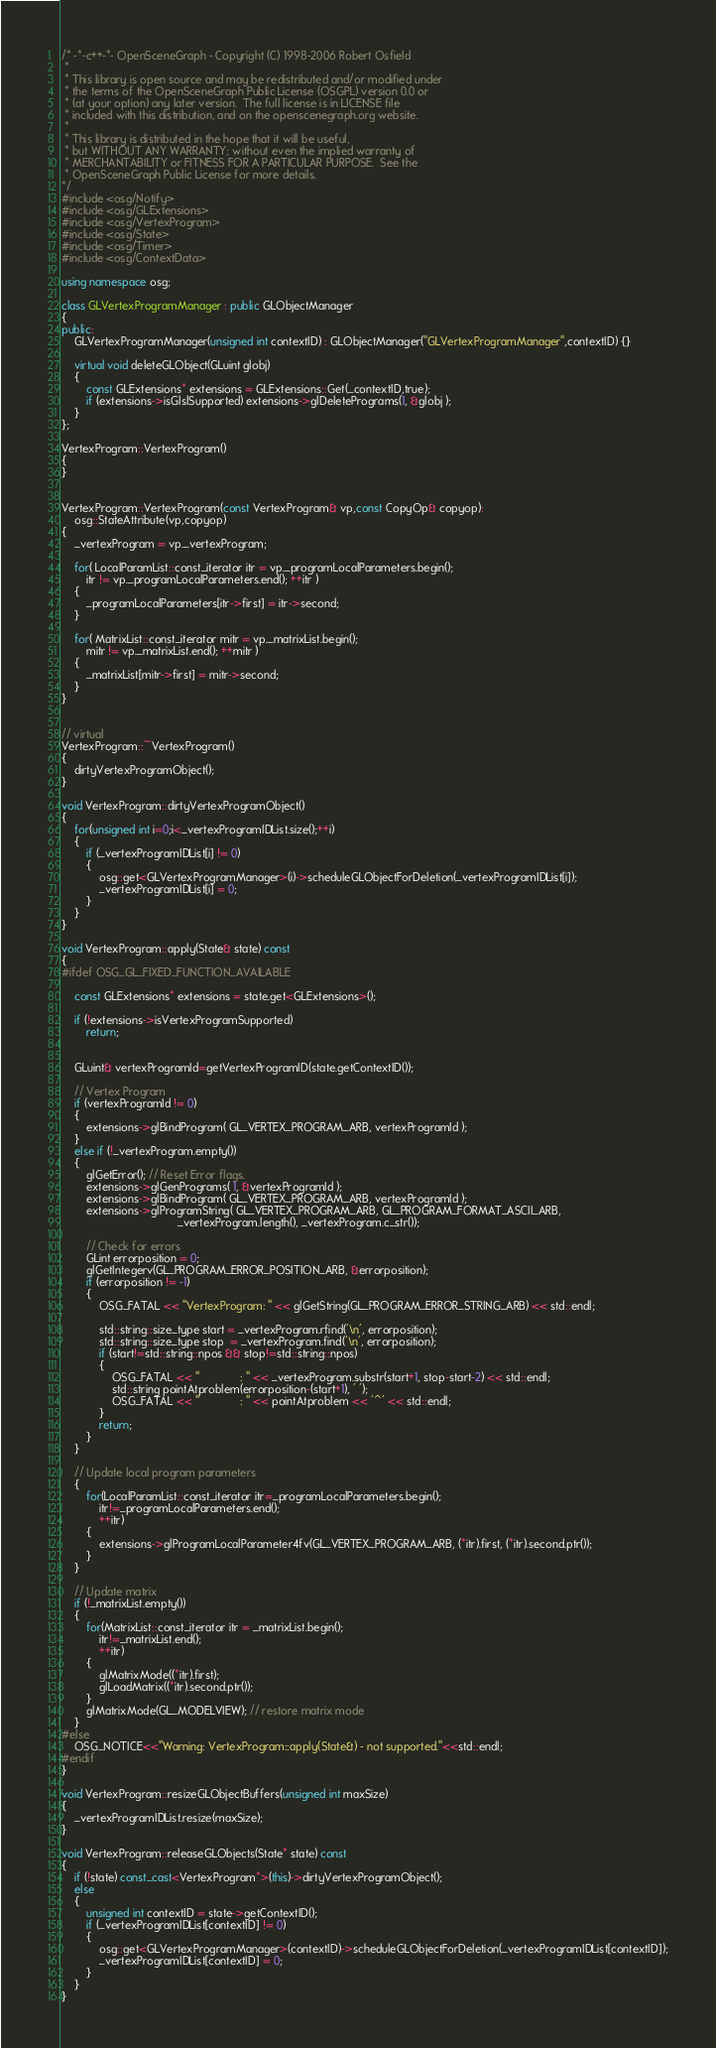Convert code to text. <code><loc_0><loc_0><loc_500><loc_500><_C++_>/* -*-c++-*- OpenSceneGraph - Copyright (C) 1998-2006 Robert Osfield
 *
 * This library is open source and may be redistributed and/or modified under
 * the terms of the OpenSceneGraph Public License (OSGPL) version 0.0 or
 * (at your option) any later version.  The full license is in LICENSE file
 * included with this distribution, and on the openscenegraph.org website.
 *
 * This library is distributed in the hope that it will be useful,
 * but WITHOUT ANY WARRANTY; without even the implied warranty of
 * MERCHANTABILITY or FITNESS FOR A PARTICULAR PURPOSE.  See the
 * OpenSceneGraph Public License for more details.
*/
#include <osg/Notify>
#include <osg/GLExtensions>
#include <osg/VertexProgram>
#include <osg/State>
#include <osg/Timer>
#include <osg/ContextData>

using namespace osg;

class GLVertexProgramManager : public GLObjectManager
{
public:
    GLVertexProgramManager(unsigned int contextID) : GLObjectManager("GLVertexProgramManager",contextID) {}

    virtual void deleteGLObject(GLuint globj)
    {
        const GLExtensions* extensions = GLExtensions::Get(_contextID,true);
        if (extensions->isGlslSupported) extensions->glDeletePrograms(1, &globj );
    }
};

VertexProgram::VertexProgram()
{
}


VertexProgram::VertexProgram(const VertexProgram& vp,const CopyOp& copyop):
    osg::StateAttribute(vp,copyop)
{
    _vertexProgram = vp._vertexProgram;

    for( LocalParamList::const_iterator itr = vp._programLocalParameters.begin();
        itr != vp._programLocalParameters.end(); ++itr )
    {
        _programLocalParameters[itr->first] = itr->second;
    }

    for( MatrixList::const_iterator mitr = vp._matrixList.begin();
        mitr != vp._matrixList.end(); ++mitr )
    {
        _matrixList[mitr->first] = mitr->second;
    }
}


// virtual
VertexProgram::~VertexProgram()
{
    dirtyVertexProgramObject();
}

void VertexProgram::dirtyVertexProgramObject()
{
    for(unsigned int i=0;i<_vertexProgramIDList.size();++i)
    {
        if (_vertexProgramIDList[i] != 0)
        {
            osg::get<GLVertexProgramManager>(i)->scheduleGLObjectForDeletion(_vertexProgramIDList[i]);
            _vertexProgramIDList[i] = 0;
        }
    }
}

void VertexProgram::apply(State& state) const
{
#ifdef OSG_GL_FIXED_FUNCTION_AVAILABLE

    const GLExtensions* extensions = state.get<GLExtensions>();

    if (!extensions->isVertexProgramSupported)
        return;


    GLuint& vertexProgramId=getVertexProgramID(state.getContextID());

    // Vertex Program
    if (vertexProgramId != 0)
    {
        extensions->glBindProgram( GL_VERTEX_PROGRAM_ARB, vertexProgramId );
    }
    else if (!_vertexProgram.empty())
    {
        glGetError(); // Reset Error flags.
        extensions->glGenPrograms( 1, &vertexProgramId );
        extensions->glBindProgram( GL_VERTEX_PROGRAM_ARB, vertexProgramId );
        extensions->glProgramString( GL_VERTEX_PROGRAM_ARB, GL_PROGRAM_FORMAT_ASCII_ARB,
                                     _vertexProgram.length(), _vertexProgram.c_str());

        // Check for errors
        GLint errorposition = 0;
        glGetIntegerv(GL_PROGRAM_ERROR_POSITION_ARB, &errorposition);
        if (errorposition != -1)
        {
            OSG_FATAL << "VertexProgram: " << glGetString(GL_PROGRAM_ERROR_STRING_ARB) << std::endl;

            std::string::size_type start = _vertexProgram.rfind('\n', errorposition);
            std::string::size_type stop  = _vertexProgram.find('\n', errorposition);
            if (start!=std::string::npos && stop!=std::string::npos)
            {
                OSG_FATAL << "             : " << _vertexProgram.substr(start+1, stop-start-2) << std::endl;
                std::string pointAtproblem(errorposition-(start+1), ' ');
                OSG_FATAL << "             : " << pointAtproblem << '^' << std::endl;
            }
            return;
        }
    }

    // Update local program parameters
    {
        for(LocalParamList::const_iterator itr=_programLocalParameters.begin();
            itr!=_programLocalParameters.end();
            ++itr)
        {
            extensions->glProgramLocalParameter4fv(GL_VERTEX_PROGRAM_ARB, (*itr).first, (*itr).second.ptr());
        }
    }

    // Update matrix
    if (!_matrixList.empty())
    {
        for(MatrixList::const_iterator itr = _matrixList.begin();
            itr!=_matrixList.end();
            ++itr)
        {
            glMatrixMode((*itr).first);
            glLoadMatrix((*itr).second.ptr());
        }
        glMatrixMode(GL_MODELVIEW); // restore matrix mode
    }
#else
    OSG_NOTICE<<"Warning: VertexProgram::apply(State&) - not supported."<<std::endl;
#endif
}

void VertexProgram::resizeGLObjectBuffers(unsigned int maxSize)
{
    _vertexProgramIDList.resize(maxSize);
}

void VertexProgram::releaseGLObjects(State* state) const
{
    if (!state) const_cast<VertexProgram*>(this)->dirtyVertexProgramObject();
    else
    {
        unsigned int contextID = state->getContextID();
        if (_vertexProgramIDList[contextID] != 0)
        {
            osg::get<GLVertexProgramManager>(contextID)->scheduleGLObjectForDeletion(_vertexProgramIDList[contextID]);
            _vertexProgramIDList[contextID] = 0;
        }
    }
}
</code> 